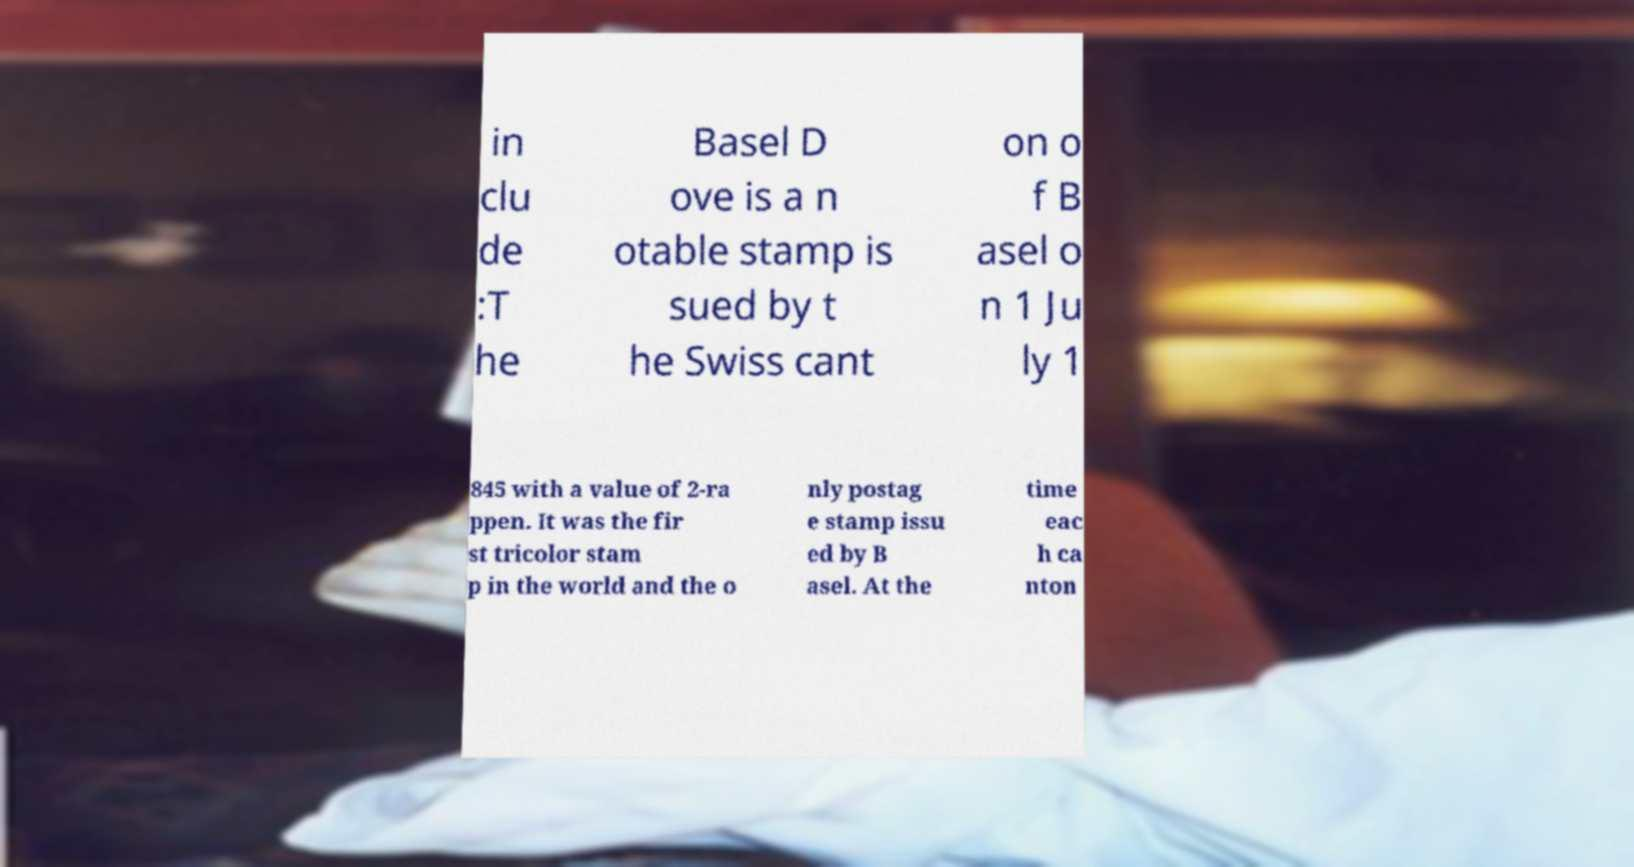There's text embedded in this image that I need extracted. Can you transcribe it verbatim? in clu de :T he Basel D ove is a n otable stamp is sued by t he Swiss cant on o f B asel o n 1 Ju ly 1 845 with a value of 2-ra ppen. It was the fir st tricolor stam p in the world and the o nly postag e stamp issu ed by B asel. At the time eac h ca nton 